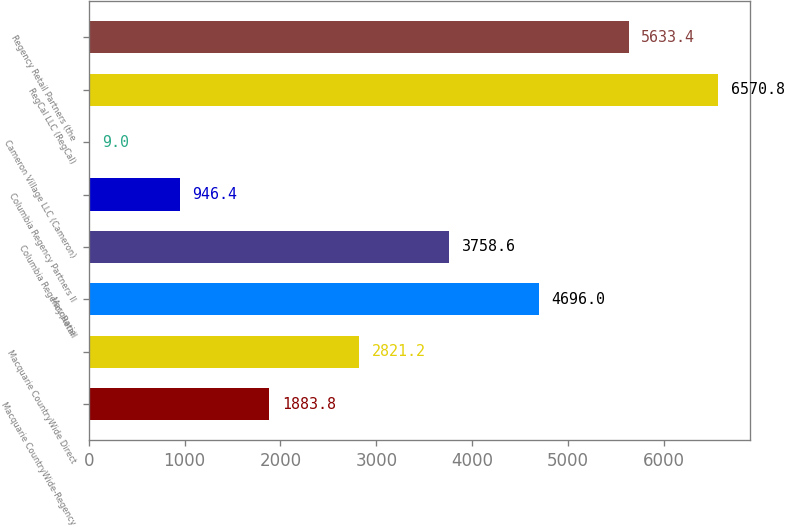Convert chart to OTSL. <chart><loc_0><loc_0><loc_500><loc_500><bar_chart><fcel>Macquarie CountryWide-Regency<fcel>Macquarie CountryWide Direct<fcel>Macquarie<fcel>Columbia Regency Retail<fcel>Columbia Regency Partners II<fcel>Cameron Village LLC (Cameron)<fcel>RegCal LLC (RegCal)<fcel>Regency Retail Partners (the<nl><fcel>1883.8<fcel>2821.2<fcel>4696<fcel>3758.6<fcel>946.4<fcel>9<fcel>6570.8<fcel>5633.4<nl></chart> 